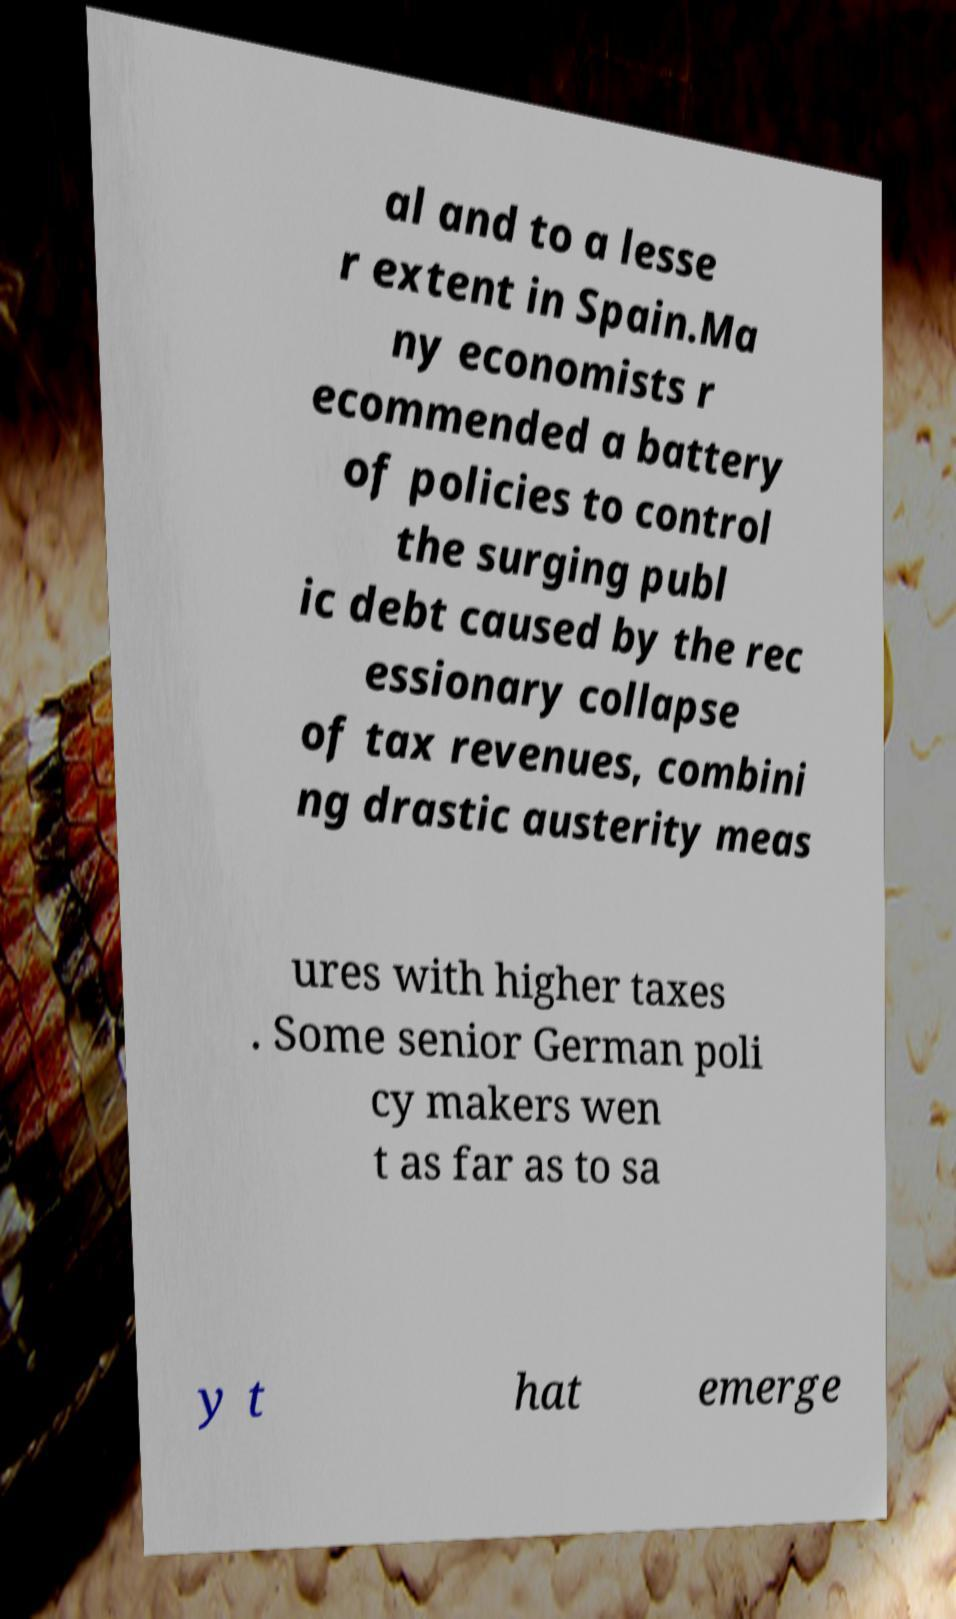Could you assist in decoding the text presented in this image and type it out clearly? al and to a lesse r extent in Spain.Ma ny economists r ecommended a battery of policies to control the surging publ ic debt caused by the rec essionary collapse of tax revenues, combini ng drastic austerity meas ures with higher taxes . Some senior German poli cy makers wen t as far as to sa y t hat emerge 